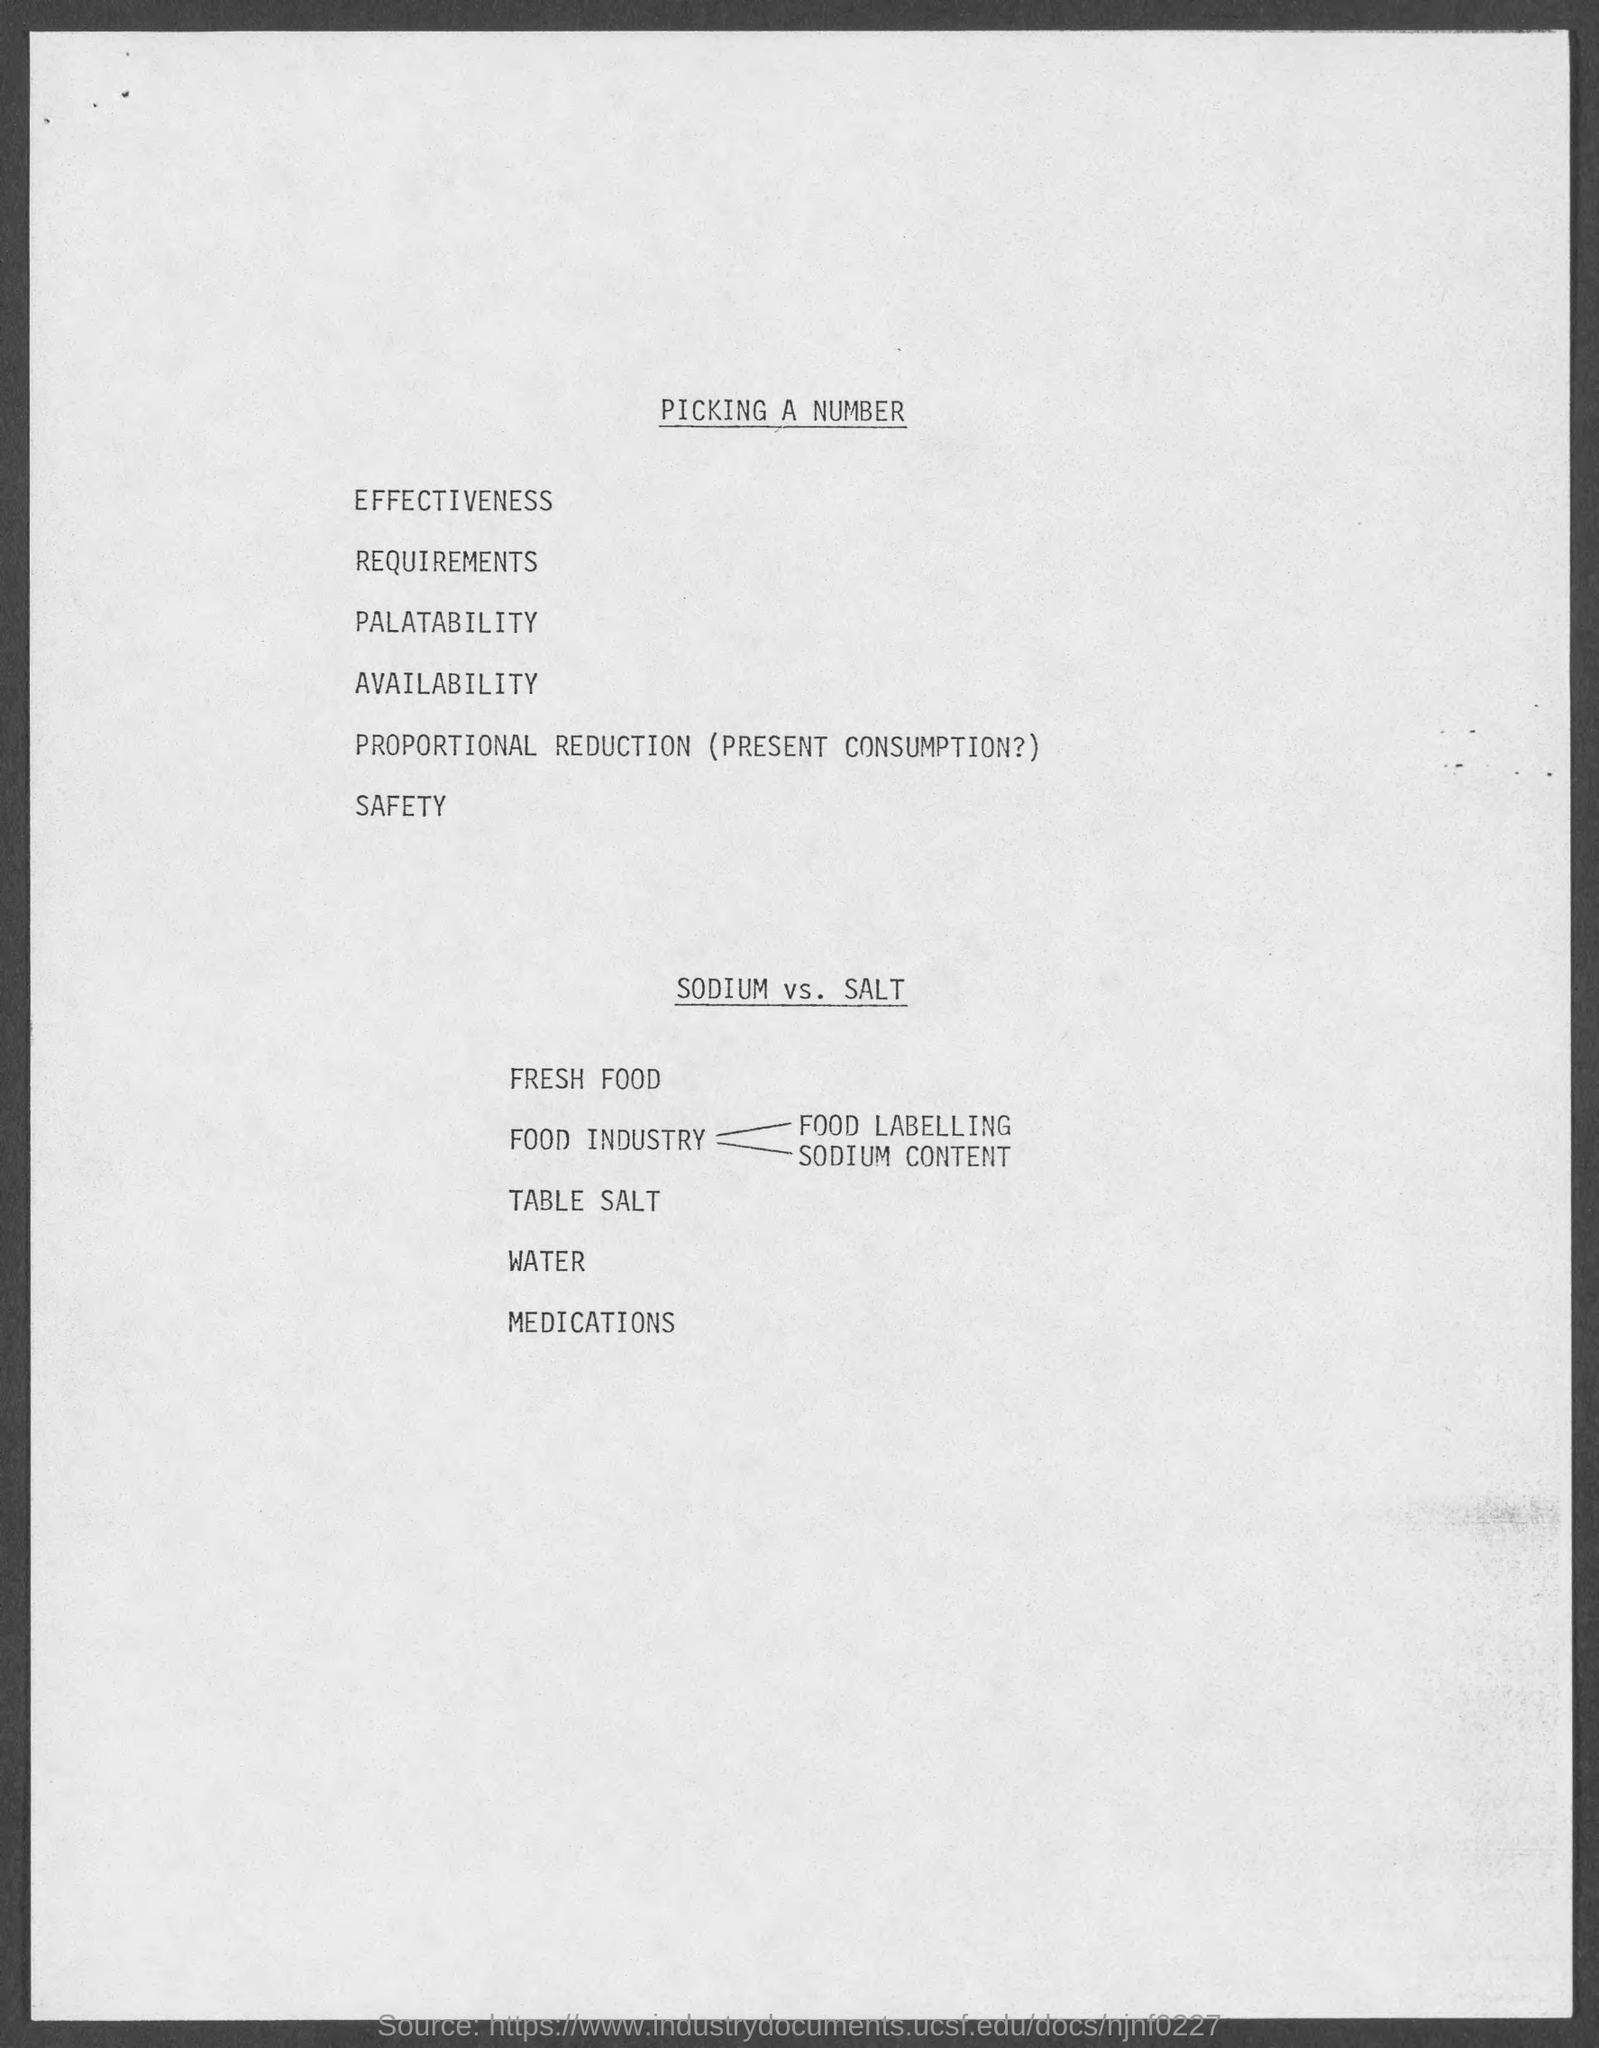What is the heading at top of the page?
Give a very brief answer. Picking a number. 